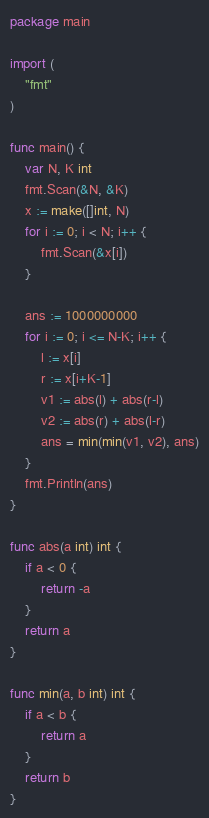Convert code to text. <code><loc_0><loc_0><loc_500><loc_500><_Go_>package main

import (
	"fmt"
)

func main() {
	var N, K int
	fmt.Scan(&N, &K)
	x := make([]int, N)
	for i := 0; i < N; i++ {
		fmt.Scan(&x[i])
	}

	ans := 1000000000
	for i := 0; i <= N-K; i++ {
		l := x[i]
		r := x[i+K-1]
		v1 := abs(l) + abs(r-l)
		v2 := abs(r) + abs(l-r)
		ans = min(min(v1, v2), ans)
	}
	fmt.Println(ans)
}

func abs(a int) int {
	if a < 0 {
		return -a
	}
	return a
}

func min(a, b int) int {
	if a < b {
		return a
	}
	return b
}
</code> 